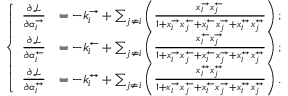Convert formula to latex. <formula><loc_0><loc_0><loc_500><loc_500>\left \{ \begin{array} { l l } { \frac { \partial \mathcal { L } } { \partial \alpha _ { i } ^ { \rightarrow } } } & { = - k _ { i } ^ { \rightarrow } + \sum _ { j \neq i } \left ( \frac { x _ { i } ^ { \rightarrow } x _ { j } ^ { \leftarrow } } { 1 + x _ { i } ^ { \rightarrow } x _ { j } ^ { \leftarrow } + x _ { i } ^ { \leftarrow } x _ { j } ^ { \rightarrow } + x _ { i } ^ { \leftrightarrow } x _ { j } ^ { \leftrightarrow } } \right ) ; } \\ { \frac { \partial \mathcal { L } } { \partial \alpha _ { i } ^ { \leftarrow } } } & { = - k _ { i } ^ { \leftarrow } + \sum _ { j \neq i } \left ( \frac { x _ { i } ^ { \leftarrow } x _ { j } ^ { \rightarrow } } { 1 + x _ { i } ^ { \rightarrow } x _ { j } ^ { \leftarrow } + x _ { i } ^ { \leftarrow } x _ { j } ^ { \rightarrow } + x _ { i } ^ { \leftrightarrow } x _ { j } ^ { \leftrightarrow } } \right ) ; } \\ { \frac { \partial \mathcal { L } } { \partial \alpha _ { i } ^ { \leftrightarrow } } } & { = - k _ { i } ^ { \leftrightarrow } + \sum _ { j \neq i } \left ( \frac { x _ { i } ^ { \leftrightarrow } x _ { j } ^ { \leftrightarrow } } { 1 + x _ { i } ^ { \rightarrow } x _ { j } ^ { \leftarrow } + x _ { i } ^ { \leftarrow } x _ { j } ^ { \rightarrow } + x _ { i } ^ { \leftrightarrow } x _ { j } ^ { \leftrightarrow } } \right ) . } \end{array}</formula> 